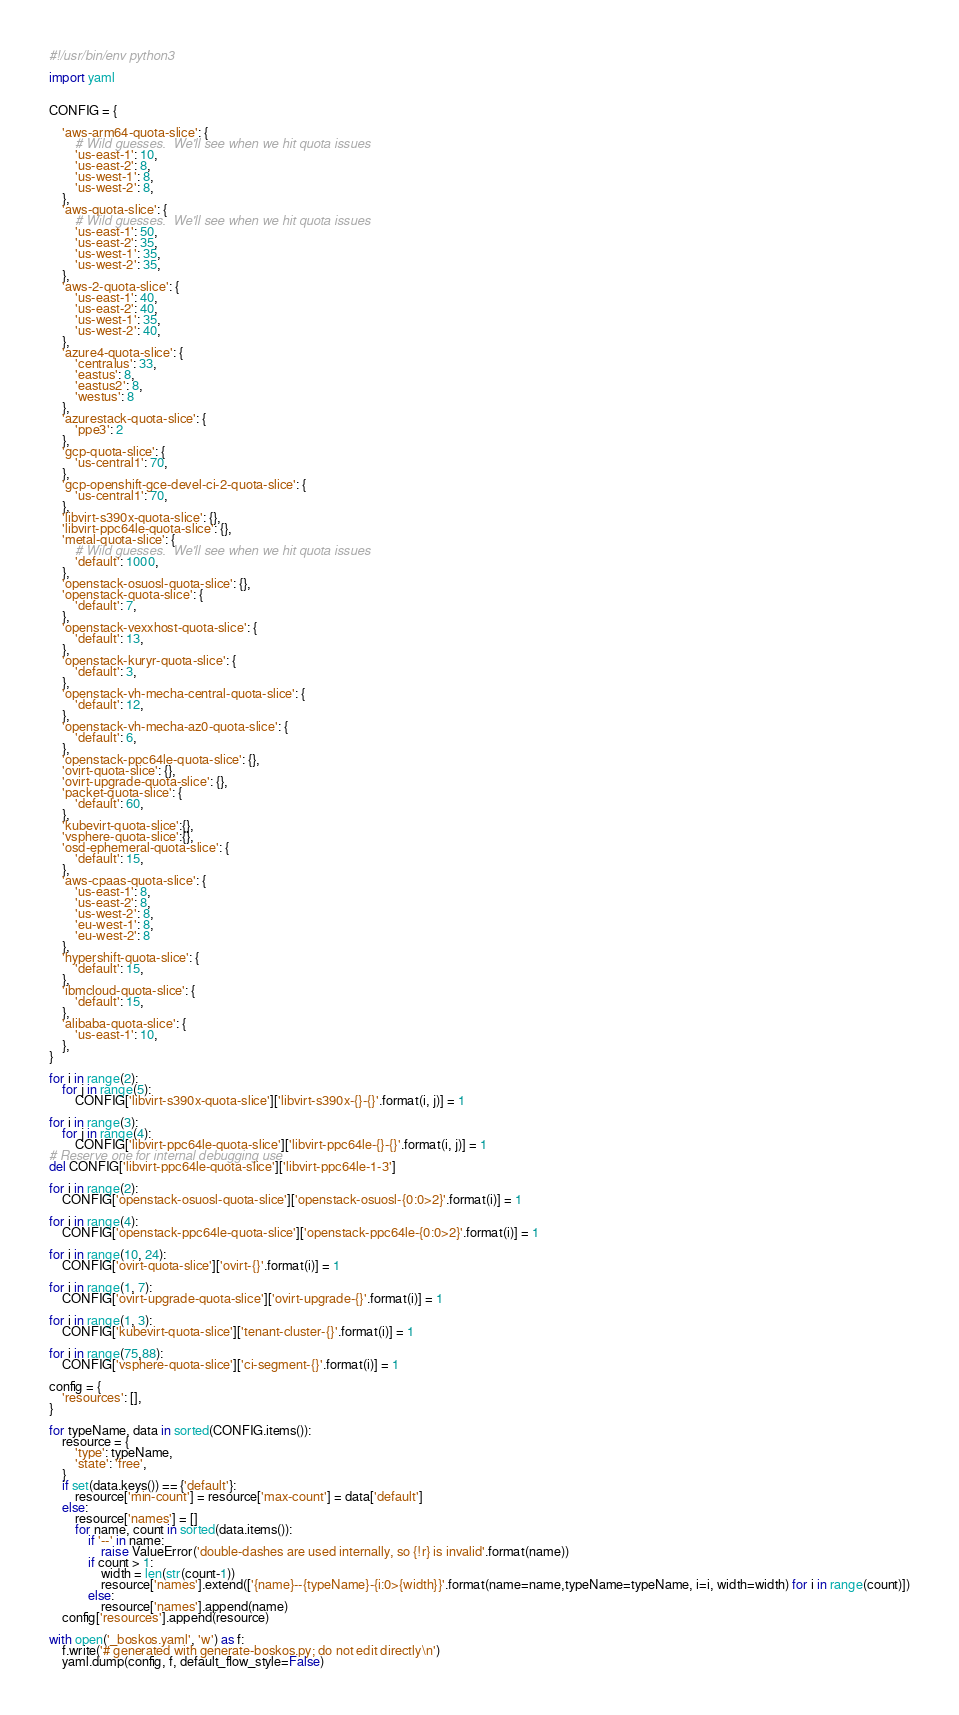<code> <loc_0><loc_0><loc_500><loc_500><_Python_>#!/usr/bin/env python3

import yaml


CONFIG = {

    'aws-arm64-quota-slice': {
        # Wild guesses.  We'll see when we hit quota issues
        'us-east-1': 10,
        'us-east-2': 8,
        'us-west-1': 8,
        'us-west-2': 8,
    },
    'aws-quota-slice': {
        # Wild guesses.  We'll see when we hit quota issues
        'us-east-1': 50,
        'us-east-2': 35,
        'us-west-1': 35,
        'us-west-2': 35,
    },
    'aws-2-quota-slice': {
        'us-east-1': 40,
        'us-east-2': 40,
        'us-west-1': 35,
        'us-west-2': 40,
    },
    'azure4-quota-slice': {
        'centralus': 33,
        'eastus': 8,
        'eastus2': 8,
        'westus': 8
    },
    'azurestack-quota-slice': {
        'ppe3': 2
    },
    'gcp-quota-slice': {
        'us-central1': 70,
    },
    'gcp-openshift-gce-devel-ci-2-quota-slice': {
        'us-central1': 70,
    },
    'libvirt-s390x-quota-slice': {},
    'libvirt-ppc64le-quota-slice': {},
    'metal-quota-slice': {
        # Wild guesses.  We'll see when we hit quota issues
        'default': 1000,
    },
    'openstack-osuosl-quota-slice': {},
    'openstack-quota-slice': {
        'default': 7,
    },
    'openstack-vexxhost-quota-slice': {
        'default': 13,
    },
    'openstack-kuryr-quota-slice': {
        'default': 3,
    },
    'openstack-vh-mecha-central-quota-slice': {
        'default': 12,
    },
    'openstack-vh-mecha-az0-quota-slice': {
        'default': 6,
    },
    'openstack-ppc64le-quota-slice': {},
    'ovirt-quota-slice': {},
    'ovirt-upgrade-quota-slice': {},
    'packet-quota-slice': {
        'default': 60,
    },
    'kubevirt-quota-slice':{},
    'vsphere-quota-slice':{},
    'osd-ephemeral-quota-slice': {
        'default': 15,
    },
    'aws-cpaas-quota-slice': {
        'us-east-1': 8,
        'us-east-2': 8,
        'us-west-2': 8,
        'eu-west-1': 8,
        'eu-west-2': 8
    },
    'hypershift-quota-slice': {
        'default': 15,
    },
    'ibmcloud-quota-slice': {
        'default': 15,
    },
    'alibaba-quota-slice': {
        'us-east-1': 10,
    },
}

for i in range(2):
    for j in range(5):
        CONFIG['libvirt-s390x-quota-slice']['libvirt-s390x-{}-{}'.format(i, j)] = 1

for i in range(3):
    for j in range(4):
        CONFIG['libvirt-ppc64le-quota-slice']['libvirt-ppc64le-{}-{}'.format(i, j)] = 1
# Reserve one for internal debugging use
del CONFIG['libvirt-ppc64le-quota-slice']['libvirt-ppc64le-1-3']

for i in range(2):
    CONFIG['openstack-osuosl-quota-slice']['openstack-osuosl-{0:0>2}'.format(i)] = 1

for i in range(4):
    CONFIG['openstack-ppc64le-quota-slice']['openstack-ppc64le-{0:0>2}'.format(i)] = 1

for i in range(10, 24):
    CONFIG['ovirt-quota-slice']['ovirt-{}'.format(i)] = 1

for i in range(1, 7):
    CONFIG['ovirt-upgrade-quota-slice']['ovirt-upgrade-{}'.format(i)] = 1

for i in range(1, 3):
    CONFIG['kubevirt-quota-slice']['tenant-cluster-{}'.format(i)] = 1

for i in range(75,88):
    CONFIG['vsphere-quota-slice']['ci-segment-{}'.format(i)] = 1

config = {
    'resources': [],
}

for typeName, data in sorted(CONFIG.items()):
    resource = {
        'type': typeName,
        'state': 'free',
    }
    if set(data.keys()) == {'default'}:
        resource['min-count'] = resource['max-count'] = data['default']
    else:
        resource['names'] = []
        for name, count in sorted(data.items()):
            if '--' in name:
                raise ValueError('double-dashes are used internally, so {!r} is invalid'.format(name))
            if count > 1:
                width = len(str(count-1))
                resource['names'].extend(['{name}--{typeName}-{i:0>{width}}'.format(name=name,typeName=typeName, i=i, width=width) for i in range(count)])
            else:
                resource['names'].append(name)
    config['resources'].append(resource)

with open('_boskos.yaml', 'w') as f:
    f.write('# generated with generate-boskos.py; do not edit directly\n')
    yaml.dump(config, f, default_flow_style=False)
</code> 